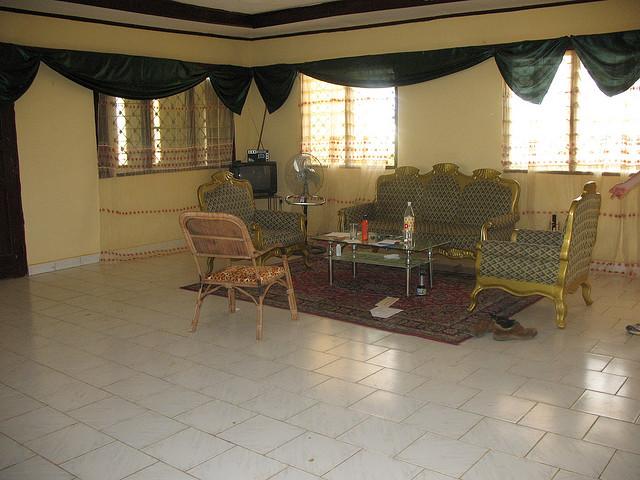What might be used to cool the room's temperature?
Short answer required. Fan. Is this a living room?
Write a very short answer. Yes. Does the furniture look comfortable?
Quick response, please. Yes. How many windows are there?
Answer briefly. 3. 